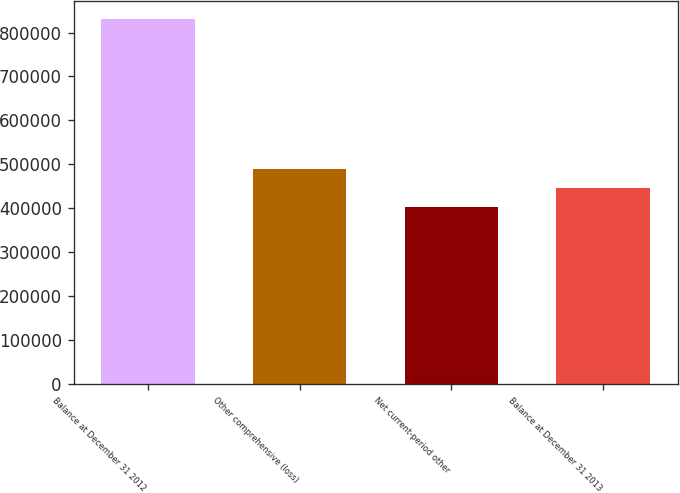<chart> <loc_0><loc_0><loc_500><loc_500><bar_chart><fcel>Balance at December 31 2012<fcel>Other comprehensive (loss)<fcel>Net current-period other<fcel>Balance at December 31 2013<nl><fcel>830403<fcel>488939<fcel>403573<fcel>446256<nl></chart> 